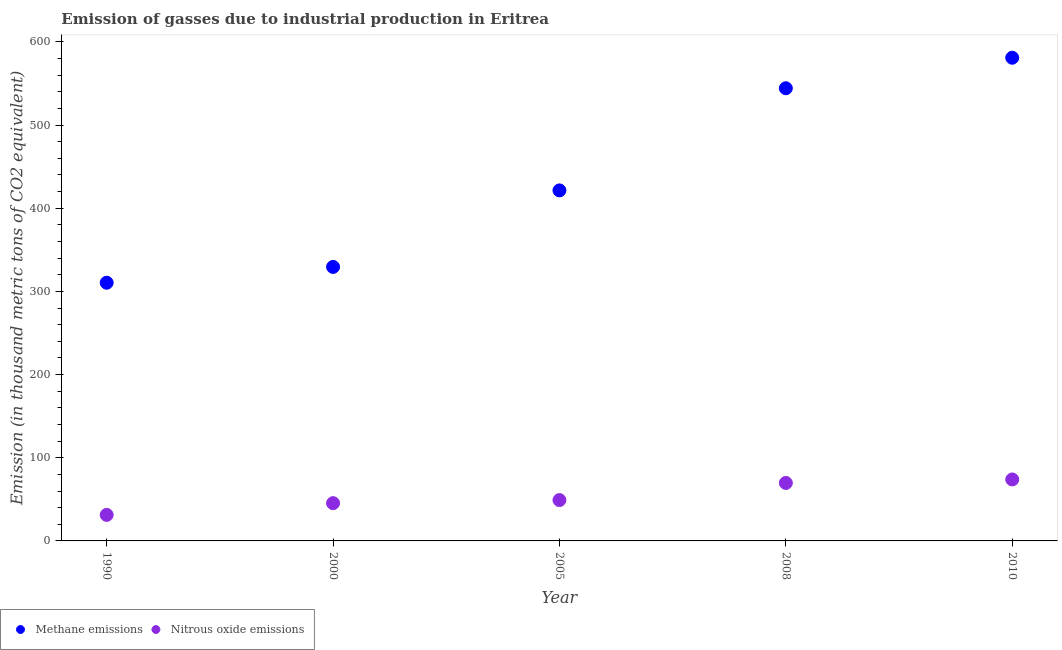How many different coloured dotlines are there?
Make the answer very short. 2. What is the amount of methane emissions in 2008?
Make the answer very short. 544.2. Across all years, what is the maximum amount of methane emissions?
Your response must be concise. 580.9. Across all years, what is the minimum amount of methane emissions?
Offer a terse response. 310.4. In which year was the amount of methane emissions maximum?
Offer a very short reply. 2010. What is the total amount of methane emissions in the graph?
Your response must be concise. 2186.3. What is the difference between the amount of methane emissions in 2000 and that in 2008?
Ensure brevity in your answer.  -214.8. What is the difference between the amount of methane emissions in 2010 and the amount of nitrous oxide emissions in 2008?
Ensure brevity in your answer.  511.2. What is the average amount of methane emissions per year?
Provide a succinct answer. 437.26. In the year 2008, what is the difference between the amount of methane emissions and amount of nitrous oxide emissions?
Your answer should be very brief. 474.5. In how many years, is the amount of methane emissions greater than 180 thousand metric tons?
Keep it short and to the point. 5. What is the ratio of the amount of nitrous oxide emissions in 2005 to that in 2008?
Provide a short and direct response. 0.7. Is the amount of methane emissions in 2005 less than that in 2010?
Make the answer very short. Yes. What is the difference between the highest and the second highest amount of methane emissions?
Your response must be concise. 36.7. What is the difference between the highest and the lowest amount of methane emissions?
Make the answer very short. 270.5. Is the amount of nitrous oxide emissions strictly less than the amount of methane emissions over the years?
Provide a succinct answer. Yes. How many years are there in the graph?
Keep it short and to the point. 5. Are the values on the major ticks of Y-axis written in scientific E-notation?
Ensure brevity in your answer.  No. Does the graph contain any zero values?
Keep it short and to the point. No. Does the graph contain grids?
Provide a succinct answer. No. How are the legend labels stacked?
Provide a short and direct response. Horizontal. What is the title of the graph?
Make the answer very short. Emission of gasses due to industrial production in Eritrea. What is the label or title of the Y-axis?
Your response must be concise. Emission (in thousand metric tons of CO2 equivalent). What is the Emission (in thousand metric tons of CO2 equivalent) of Methane emissions in 1990?
Give a very brief answer. 310.4. What is the Emission (in thousand metric tons of CO2 equivalent) of Nitrous oxide emissions in 1990?
Your answer should be very brief. 31.3. What is the Emission (in thousand metric tons of CO2 equivalent) of Methane emissions in 2000?
Ensure brevity in your answer.  329.4. What is the Emission (in thousand metric tons of CO2 equivalent) in Nitrous oxide emissions in 2000?
Give a very brief answer. 45.4. What is the Emission (in thousand metric tons of CO2 equivalent) of Methane emissions in 2005?
Give a very brief answer. 421.4. What is the Emission (in thousand metric tons of CO2 equivalent) in Nitrous oxide emissions in 2005?
Your answer should be compact. 49.1. What is the Emission (in thousand metric tons of CO2 equivalent) of Methane emissions in 2008?
Offer a terse response. 544.2. What is the Emission (in thousand metric tons of CO2 equivalent) in Nitrous oxide emissions in 2008?
Your response must be concise. 69.7. What is the Emission (in thousand metric tons of CO2 equivalent) of Methane emissions in 2010?
Keep it short and to the point. 580.9. What is the Emission (in thousand metric tons of CO2 equivalent) of Nitrous oxide emissions in 2010?
Give a very brief answer. 73.9. Across all years, what is the maximum Emission (in thousand metric tons of CO2 equivalent) of Methane emissions?
Provide a short and direct response. 580.9. Across all years, what is the maximum Emission (in thousand metric tons of CO2 equivalent) in Nitrous oxide emissions?
Keep it short and to the point. 73.9. Across all years, what is the minimum Emission (in thousand metric tons of CO2 equivalent) in Methane emissions?
Keep it short and to the point. 310.4. Across all years, what is the minimum Emission (in thousand metric tons of CO2 equivalent) of Nitrous oxide emissions?
Your response must be concise. 31.3. What is the total Emission (in thousand metric tons of CO2 equivalent) of Methane emissions in the graph?
Provide a succinct answer. 2186.3. What is the total Emission (in thousand metric tons of CO2 equivalent) of Nitrous oxide emissions in the graph?
Offer a terse response. 269.4. What is the difference between the Emission (in thousand metric tons of CO2 equivalent) of Nitrous oxide emissions in 1990 and that in 2000?
Make the answer very short. -14.1. What is the difference between the Emission (in thousand metric tons of CO2 equivalent) in Methane emissions in 1990 and that in 2005?
Make the answer very short. -111. What is the difference between the Emission (in thousand metric tons of CO2 equivalent) in Nitrous oxide emissions in 1990 and that in 2005?
Your answer should be compact. -17.8. What is the difference between the Emission (in thousand metric tons of CO2 equivalent) in Methane emissions in 1990 and that in 2008?
Keep it short and to the point. -233.8. What is the difference between the Emission (in thousand metric tons of CO2 equivalent) of Nitrous oxide emissions in 1990 and that in 2008?
Provide a short and direct response. -38.4. What is the difference between the Emission (in thousand metric tons of CO2 equivalent) of Methane emissions in 1990 and that in 2010?
Offer a very short reply. -270.5. What is the difference between the Emission (in thousand metric tons of CO2 equivalent) in Nitrous oxide emissions in 1990 and that in 2010?
Your answer should be compact. -42.6. What is the difference between the Emission (in thousand metric tons of CO2 equivalent) in Methane emissions in 2000 and that in 2005?
Your answer should be very brief. -92. What is the difference between the Emission (in thousand metric tons of CO2 equivalent) in Methane emissions in 2000 and that in 2008?
Your response must be concise. -214.8. What is the difference between the Emission (in thousand metric tons of CO2 equivalent) of Nitrous oxide emissions in 2000 and that in 2008?
Keep it short and to the point. -24.3. What is the difference between the Emission (in thousand metric tons of CO2 equivalent) in Methane emissions in 2000 and that in 2010?
Your response must be concise. -251.5. What is the difference between the Emission (in thousand metric tons of CO2 equivalent) in Nitrous oxide emissions in 2000 and that in 2010?
Make the answer very short. -28.5. What is the difference between the Emission (in thousand metric tons of CO2 equivalent) in Methane emissions in 2005 and that in 2008?
Your response must be concise. -122.8. What is the difference between the Emission (in thousand metric tons of CO2 equivalent) of Nitrous oxide emissions in 2005 and that in 2008?
Keep it short and to the point. -20.6. What is the difference between the Emission (in thousand metric tons of CO2 equivalent) in Methane emissions in 2005 and that in 2010?
Offer a very short reply. -159.5. What is the difference between the Emission (in thousand metric tons of CO2 equivalent) of Nitrous oxide emissions in 2005 and that in 2010?
Provide a short and direct response. -24.8. What is the difference between the Emission (in thousand metric tons of CO2 equivalent) of Methane emissions in 2008 and that in 2010?
Provide a succinct answer. -36.7. What is the difference between the Emission (in thousand metric tons of CO2 equivalent) in Methane emissions in 1990 and the Emission (in thousand metric tons of CO2 equivalent) in Nitrous oxide emissions in 2000?
Offer a very short reply. 265. What is the difference between the Emission (in thousand metric tons of CO2 equivalent) of Methane emissions in 1990 and the Emission (in thousand metric tons of CO2 equivalent) of Nitrous oxide emissions in 2005?
Give a very brief answer. 261.3. What is the difference between the Emission (in thousand metric tons of CO2 equivalent) in Methane emissions in 1990 and the Emission (in thousand metric tons of CO2 equivalent) in Nitrous oxide emissions in 2008?
Your answer should be very brief. 240.7. What is the difference between the Emission (in thousand metric tons of CO2 equivalent) of Methane emissions in 1990 and the Emission (in thousand metric tons of CO2 equivalent) of Nitrous oxide emissions in 2010?
Ensure brevity in your answer.  236.5. What is the difference between the Emission (in thousand metric tons of CO2 equivalent) in Methane emissions in 2000 and the Emission (in thousand metric tons of CO2 equivalent) in Nitrous oxide emissions in 2005?
Offer a very short reply. 280.3. What is the difference between the Emission (in thousand metric tons of CO2 equivalent) in Methane emissions in 2000 and the Emission (in thousand metric tons of CO2 equivalent) in Nitrous oxide emissions in 2008?
Your response must be concise. 259.7. What is the difference between the Emission (in thousand metric tons of CO2 equivalent) of Methane emissions in 2000 and the Emission (in thousand metric tons of CO2 equivalent) of Nitrous oxide emissions in 2010?
Keep it short and to the point. 255.5. What is the difference between the Emission (in thousand metric tons of CO2 equivalent) in Methane emissions in 2005 and the Emission (in thousand metric tons of CO2 equivalent) in Nitrous oxide emissions in 2008?
Your response must be concise. 351.7. What is the difference between the Emission (in thousand metric tons of CO2 equivalent) of Methane emissions in 2005 and the Emission (in thousand metric tons of CO2 equivalent) of Nitrous oxide emissions in 2010?
Give a very brief answer. 347.5. What is the difference between the Emission (in thousand metric tons of CO2 equivalent) in Methane emissions in 2008 and the Emission (in thousand metric tons of CO2 equivalent) in Nitrous oxide emissions in 2010?
Provide a succinct answer. 470.3. What is the average Emission (in thousand metric tons of CO2 equivalent) in Methane emissions per year?
Provide a succinct answer. 437.26. What is the average Emission (in thousand metric tons of CO2 equivalent) in Nitrous oxide emissions per year?
Your response must be concise. 53.88. In the year 1990, what is the difference between the Emission (in thousand metric tons of CO2 equivalent) in Methane emissions and Emission (in thousand metric tons of CO2 equivalent) in Nitrous oxide emissions?
Ensure brevity in your answer.  279.1. In the year 2000, what is the difference between the Emission (in thousand metric tons of CO2 equivalent) in Methane emissions and Emission (in thousand metric tons of CO2 equivalent) in Nitrous oxide emissions?
Provide a short and direct response. 284. In the year 2005, what is the difference between the Emission (in thousand metric tons of CO2 equivalent) in Methane emissions and Emission (in thousand metric tons of CO2 equivalent) in Nitrous oxide emissions?
Offer a very short reply. 372.3. In the year 2008, what is the difference between the Emission (in thousand metric tons of CO2 equivalent) of Methane emissions and Emission (in thousand metric tons of CO2 equivalent) of Nitrous oxide emissions?
Your answer should be very brief. 474.5. In the year 2010, what is the difference between the Emission (in thousand metric tons of CO2 equivalent) of Methane emissions and Emission (in thousand metric tons of CO2 equivalent) of Nitrous oxide emissions?
Give a very brief answer. 507. What is the ratio of the Emission (in thousand metric tons of CO2 equivalent) of Methane emissions in 1990 to that in 2000?
Your answer should be compact. 0.94. What is the ratio of the Emission (in thousand metric tons of CO2 equivalent) of Nitrous oxide emissions in 1990 to that in 2000?
Offer a terse response. 0.69. What is the ratio of the Emission (in thousand metric tons of CO2 equivalent) of Methane emissions in 1990 to that in 2005?
Offer a terse response. 0.74. What is the ratio of the Emission (in thousand metric tons of CO2 equivalent) of Nitrous oxide emissions in 1990 to that in 2005?
Provide a succinct answer. 0.64. What is the ratio of the Emission (in thousand metric tons of CO2 equivalent) in Methane emissions in 1990 to that in 2008?
Your answer should be very brief. 0.57. What is the ratio of the Emission (in thousand metric tons of CO2 equivalent) in Nitrous oxide emissions in 1990 to that in 2008?
Give a very brief answer. 0.45. What is the ratio of the Emission (in thousand metric tons of CO2 equivalent) in Methane emissions in 1990 to that in 2010?
Provide a short and direct response. 0.53. What is the ratio of the Emission (in thousand metric tons of CO2 equivalent) in Nitrous oxide emissions in 1990 to that in 2010?
Give a very brief answer. 0.42. What is the ratio of the Emission (in thousand metric tons of CO2 equivalent) of Methane emissions in 2000 to that in 2005?
Keep it short and to the point. 0.78. What is the ratio of the Emission (in thousand metric tons of CO2 equivalent) in Nitrous oxide emissions in 2000 to that in 2005?
Your answer should be compact. 0.92. What is the ratio of the Emission (in thousand metric tons of CO2 equivalent) in Methane emissions in 2000 to that in 2008?
Offer a terse response. 0.61. What is the ratio of the Emission (in thousand metric tons of CO2 equivalent) of Nitrous oxide emissions in 2000 to that in 2008?
Give a very brief answer. 0.65. What is the ratio of the Emission (in thousand metric tons of CO2 equivalent) in Methane emissions in 2000 to that in 2010?
Offer a very short reply. 0.57. What is the ratio of the Emission (in thousand metric tons of CO2 equivalent) in Nitrous oxide emissions in 2000 to that in 2010?
Make the answer very short. 0.61. What is the ratio of the Emission (in thousand metric tons of CO2 equivalent) in Methane emissions in 2005 to that in 2008?
Your answer should be very brief. 0.77. What is the ratio of the Emission (in thousand metric tons of CO2 equivalent) of Nitrous oxide emissions in 2005 to that in 2008?
Provide a succinct answer. 0.7. What is the ratio of the Emission (in thousand metric tons of CO2 equivalent) of Methane emissions in 2005 to that in 2010?
Offer a terse response. 0.73. What is the ratio of the Emission (in thousand metric tons of CO2 equivalent) in Nitrous oxide emissions in 2005 to that in 2010?
Offer a very short reply. 0.66. What is the ratio of the Emission (in thousand metric tons of CO2 equivalent) of Methane emissions in 2008 to that in 2010?
Your answer should be very brief. 0.94. What is the ratio of the Emission (in thousand metric tons of CO2 equivalent) of Nitrous oxide emissions in 2008 to that in 2010?
Ensure brevity in your answer.  0.94. What is the difference between the highest and the second highest Emission (in thousand metric tons of CO2 equivalent) of Methane emissions?
Give a very brief answer. 36.7. What is the difference between the highest and the lowest Emission (in thousand metric tons of CO2 equivalent) of Methane emissions?
Your response must be concise. 270.5. What is the difference between the highest and the lowest Emission (in thousand metric tons of CO2 equivalent) of Nitrous oxide emissions?
Your answer should be compact. 42.6. 